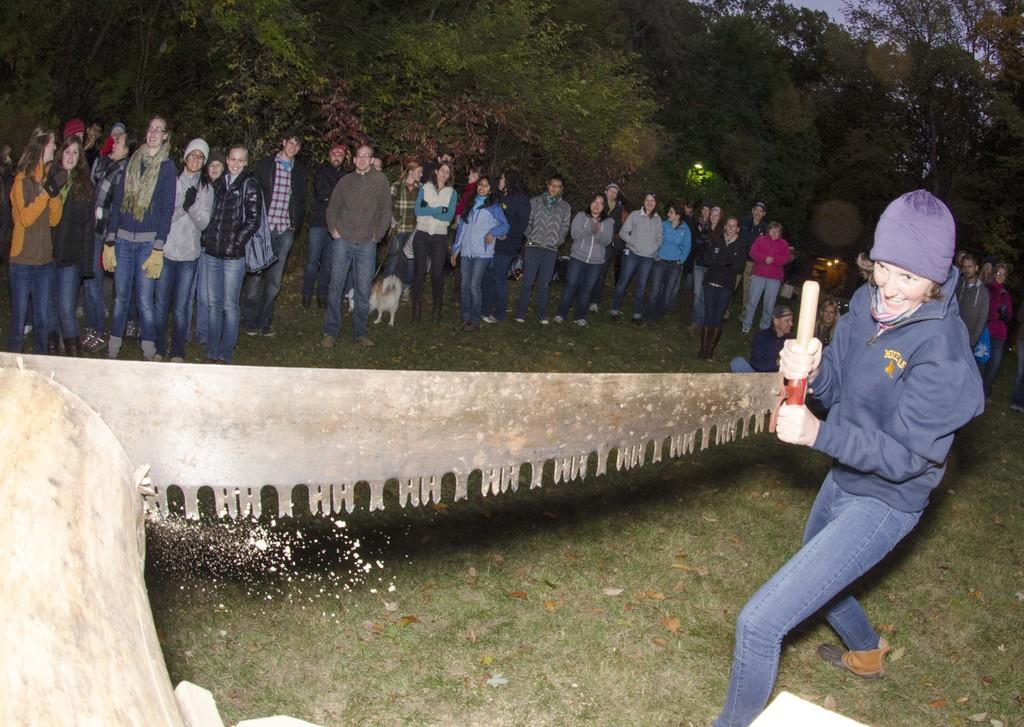What is the person in the image doing? The person is cutting a piece of wood. What tool is the person using to cut the wood? The person is holding a hand saw. What can be seen on the person's head? The person is wearing a cap. What is happening in the background of the image? There is a group of people standing on the ground, and trees are visible in the background. How many units of water are the brothers swimming in the image? There are no brothers or swimming activity present in the image. 